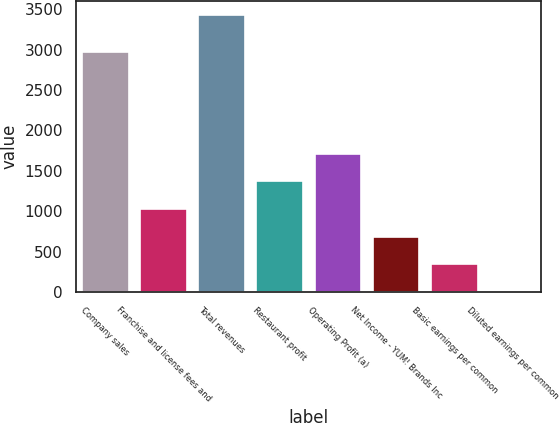<chart> <loc_0><loc_0><loc_500><loc_500><bar_chart><fcel>Company sales<fcel>Franchise and license fees and<fcel>Total revenues<fcel>Restaurant profit<fcel>Operating Profit (a)<fcel>Net Income - YUM! Brands Inc<fcel>Basic earnings per common<fcel>Diluted earnings per common<nl><fcel>2968<fcel>1028.76<fcel>3427<fcel>1371.37<fcel>1713.97<fcel>686.16<fcel>343.56<fcel>0.95<nl></chart> 